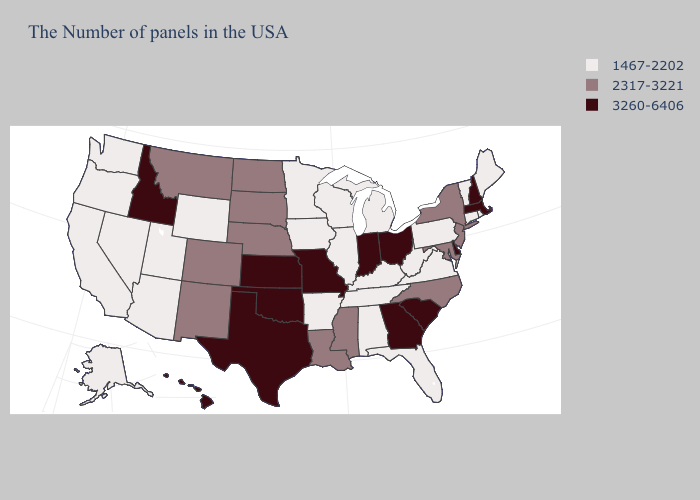Which states have the lowest value in the West?
Write a very short answer. Wyoming, Utah, Arizona, Nevada, California, Washington, Oregon, Alaska. Does the map have missing data?
Write a very short answer. No. Does New Jersey have a lower value than Iowa?
Concise answer only. No. Among the states that border South Carolina , does Georgia have the highest value?
Concise answer only. Yes. Which states have the lowest value in the South?
Keep it brief. Virginia, West Virginia, Florida, Kentucky, Alabama, Tennessee, Arkansas. Name the states that have a value in the range 3260-6406?
Write a very short answer. Massachusetts, New Hampshire, Delaware, South Carolina, Ohio, Georgia, Indiana, Missouri, Kansas, Oklahoma, Texas, Idaho, Hawaii. Which states have the lowest value in the USA?
Quick response, please. Maine, Rhode Island, Vermont, Connecticut, Pennsylvania, Virginia, West Virginia, Florida, Michigan, Kentucky, Alabama, Tennessee, Wisconsin, Illinois, Arkansas, Minnesota, Iowa, Wyoming, Utah, Arizona, Nevada, California, Washington, Oregon, Alaska. Among the states that border Montana , which have the highest value?
Short answer required. Idaho. Among the states that border New Jersey , which have the lowest value?
Give a very brief answer. Pennsylvania. What is the value of Massachusetts?
Give a very brief answer. 3260-6406. What is the highest value in states that border Vermont?
Quick response, please. 3260-6406. What is the highest value in the USA?
Be succinct. 3260-6406. What is the highest value in the USA?
Write a very short answer. 3260-6406. What is the value of Kansas?
Quick response, please. 3260-6406. 